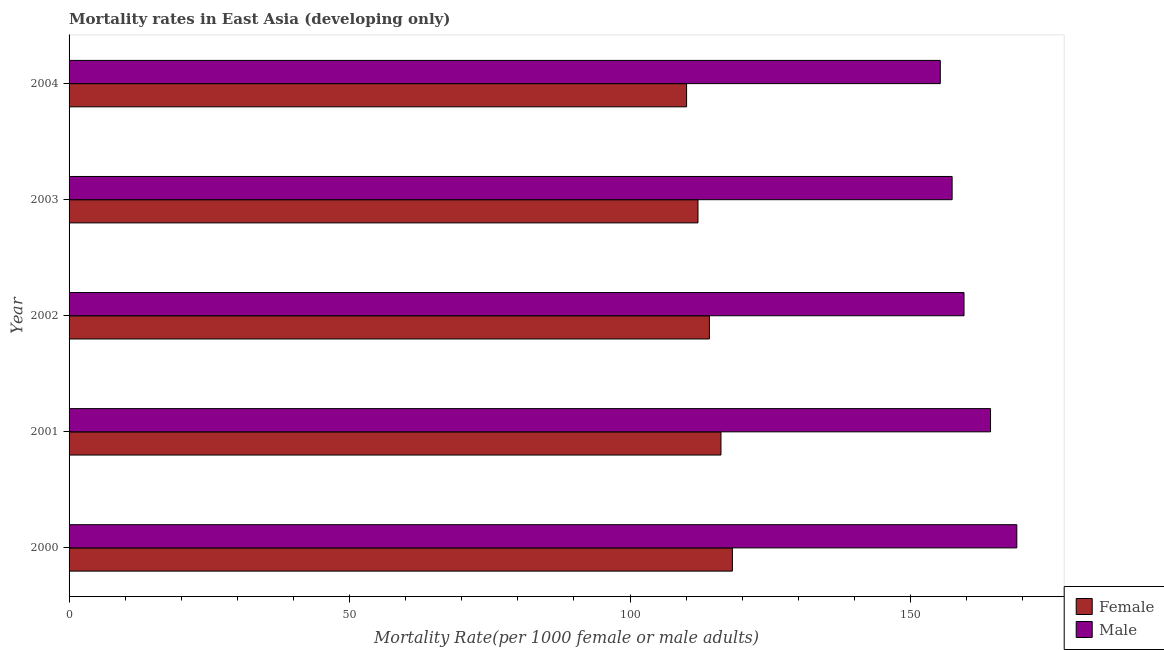What is the female mortality rate in 2004?
Your answer should be very brief. 110.07. Across all years, what is the maximum female mortality rate?
Make the answer very short. 118.24. Across all years, what is the minimum male mortality rate?
Your answer should be very brief. 155.29. In which year was the female mortality rate minimum?
Your answer should be very brief. 2004. What is the total female mortality rate in the graph?
Offer a terse response. 570.75. What is the difference between the male mortality rate in 2002 and that in 2004?
Offer a terse response. 4.23. What is the difference between the male mortality rate in 2000 and the female mortality rate in 2003?
Keep it short and to the point. 56.83. What is the average female mortality rate per year?
Give a very brief answer. 114.15. In the year 2002, what is the difference between the male mortality rate and female mortality rate?
Keep it short and to the point. 45.39. What is the ratio of the female mortality rate in 2000 to that in 2002?
Your response must be concise. 1.04. Is the female mortality rate in 2001 less than that in 2003?
Provide a succinct answer. No. What is the difference between the highest and the second highest male mortality rate?
Your answer should be compact. 4.68. What is the difference between the highest and the lowest female mortality rate?
Offer a very short reply. 8.17. Is the sum of the male mortality rate in 2002 and 2003 greater than the maximum female mortality rate across all years?
Provide a succinct answer. Yes. What does the 2nd bar from the bottom in 2003 represents?
Keep it short and to the point. Male. Are all the bars in the graph horizontal?
Keep it short and to the point. Yes. Are the values on the major ticks of X-axis written in scientific E-notation?
Provide a short and direct response. No. Does the graph contain any zero values?
Make the answer very short. No. How many legend labels are there?
Give a very brief answer. 2. How are the legend labels stacked?
Provide a succinct answer. Vertical. What is the title of the graph?
Keep it short and to the point. Mortality rates in East Asia (developing only). What is the label or title of the X-axis?
Your answer should be very brief. Mortality Rate(per 1000 female or male adults). What is the Mortality Rate(per 1000 female or male adults) of Female in 2000?
Give a very brief answer. 118.24. What is the Mortality Rate(per 1000 female or male adults) in Male in 2000?
Keep it short and to the point. 168.93. What is the Mortality Rate(per 1000 female or male adults) in Female in 2001?
Provide a short and direct response. 116.2. What is the Mortality Rate(per 1000 female or male adults) in Male in 2001?
Provide a short and direct response. 164.25. What is the Mortality Rate(per 1000 female or male adults) of Female in 2002?
Provide a short and direct response. 114.14. What is the Mortality Rate(per 1000 female or male adults) in Male in 2002?
Your answer should be compact. 159.52. What is the Mortality Rate(per 1000 female or male adults) in Female in 2003?
Your answer should be compact. 112.1. What is the Mortality Rate(per 1000 female or male adults) of Male in 2003?
Your response must be concise. 157.4. What is the Mortality Rate(per 1000 female or male adults) in Female in 2004?
Ensure brevity in your answer.  110.07. What is the Mortality Rate(per 1000 female or male adults) of Male in 2004?
Your answer should be compact. 155.29. Across all years, what is the maximum Mortality Rate(per 1000 female or male adults) in Female?
Your answer should be compact. 118.24. Across all years, what is the maximum Mortality Rate(per 1000 female or male adults) of Male?
Offer a terse response. 168.93. Across all years, what is the minimum Mortality Rate(per 1000 female or male adults) in Female?
Keep it short and to the point. 110.07. Across all years, what is the minimum Mortality Rate(per 1000 female or male adults) of Male?
Offer a very short reply. 155.29. What is the total Mortality Rate(per 1000 female or male adults) in Female in the graph?
Give a very brief answer. 570.75. What is the total Mortality Rate(per 1000 female or male adults) of Male in the graph?
Offer a terse response. 805.41. What is the difference between the Mortality Rate(per 1000 female or male adults) in Female in 2000 and that in 2001?
Make the answer very short. 2.04. What is the difference between the Mortality Rate(per 1000 female or male adults) in Male in 2000 and that in 2001?
Your answer should be compact. 4.68. What is the difference between the Mortality Rate(per 1000 female or male adults) in Female in 2000 and that in 2002?
Your response must be concise. 4.1. What is the difference between the Mortality Rate(per 1000 female or male adults) of Male in 2000 and that in 2002?
Your answer should be compact. 9.41. What is the difference between the Mortality Rate(per 1000 female or male adults) of Female in 2000 and that in 2003?
Make the answer very short. 6.13. What is the difference between the Mortality Rate(per 1000 female or male adults) of Male in 2000 and that in 2003?
Your answer should be very brief. 11.53. What is the difference between the Mortality Rate(per 1000 female or male adults) in Female in 2000 and that in 2004?
Offer a terse response. 8.17. What is the difference between the Mortality Rate(per 1000 female or male adults) in Male in 2000 and that in 2004?
Give a very brief answer. 13.64. What is the difference between the Mortality Rate(per 1000 female or male adults) in Female in 2001 and that in 2002?
Provide a short and direct response. 2.06. What is the difference between the Mortality Rate(per 1000 female or male adults) of Male in 2001 and that in 2002?
Ensure brevity in your answer.  4.73. What is the difference between the Mortality Rate(per 1000 female or male adults) of Female in 2001 and that in 2003?
Provide a succinct answer. 4.1. What is the difference between the Mortality Rate(per 1000 female or male adults) of Male in 2001 and that in 2003?
Provide a short and direct response. 6.85. What is the difference between the Mortality Rate(per 1000 female or male adults) in Female in 2001 and that in 2004?
Provide a short and direct response. 6.13. What is the difference between the Mortality Rate(per 1000 female or male adults) of Male in 2001 and that in 2004?
Make the answer very short. 8.96. What is the difference between the Mortality Rate(per 1000 female or male adults) in Female in 2002 and that in 2003?
Your answer should be compact. 2.03. What is the difference between the Mortality Rate(per 1000 female or male adults) in Male in 2002 and that in 2003?
Provide a short and direct response. 2.12. What is the difference between the Mortality Rate(per 1000 female or male adults) in Female in 2002 and that in 2004?
Provide a succinct answer. 4.07. What is the difference between the Mortality Rate(per 1000 female or male adults) in Male in 2002 and that in 2004?
Ensure brevity in your answer.  4.23. What is the difference between the Mortality Rate(per 1000 female or male adults) in Female in 2003 and that in 2004?
Offer a very short reply. 2.03. What is the difference between the Mortality Rate(per 1000 female or male adults) in Male in 2003 and that in 2004?
Your answer should be compact. 2.11. What is the difference between the Mortality Rate(per 1000 female or male adults) in Female in 2000 and the Mortality Rate(per 1000 female or male adults) in Male in 2001?
Offer a very short reply. -46.01. What is the difference between the Mortality Rate(per 1000 female or male adults) in Female in 2000 and the Mortality Rate(per 1000 female or male adults) in Male in 2002?
Offer a terse response. -41.29. What is the difference between the Mortality Rate(per 1000 female or male adults) of Female in 2000 and the Mortality Rate(per 1000 female or male adults) of Male in 2003?
Provide a succinct answer. -39.17. What is the difference between the Mortality Rate(per 1000 female or male adults) in Female in 2000 and the Mortality Rate(per 1000 female or male adults) in Male in 2004?
Offer a very short reply. -37.06. What is the difference between the Mortality Rate(per 1000 female or male adults) in Female in 2001 and the Mortality Rate(per 1000 female or male adults) in Male in 2002?
Give a very brief answer. -43.32. What is the difference between the Mortality Rate(per 1000 female or male adults) in Female in 2001 and the Mortality Rate(per 1000 female or male adults) in Male in 2003?
Give a very brief answer. -41.2. What is the difference between the Mortality Rate(per 1000 female or male adults) of Female in 2001 and the Mortality Rate(per 1000 female or male adults) of Male in 2004?
Give a very brief answer. -39.1. What is the difference between the Mortality Rate(per 1000 female or male adults) of Female in 2002 and the Mortality Rate(per 1000 female or male adults) of Male in 2003?
Your response must be concise. -43.27. What is the difference between the Mortality Rate(per 1000 female or male adults) in Female in 2002 and the Mortality Rate(per 1000 female or male adults) in Male in 2004?
Make the answer very short. -41.16. What is the difference between the Mortality Rate(per 1000 female or male adults) of Female in 2003 and the Mortality Rate(per 1000 female or male adults) of Male in 2004?
Offer a very short reply. -43.19. What is the average Mortality Rate(per 1000 female or male adults) in Female per year?
Offer a very short reply. 114.15. What is the average Mortality Rate(per 1000 female or male adults) in Male per year?
Provide a short and direct response. 161.08. In the year 2000, what is the difference between the Mortality Rate(per 1000 female or male adults) of Female and Mortality Rate(per 1000 female or male adults) of Male?
Your answer should be very brief. -50.7. In the year 2001, what is the difference between the Mortality Rate(per 1000 female or male adults) of Female and Mortality Rate(per 1000 female or male adults) of Male?
Keep it short and to the point. -48.05. In the year 2002, what is the difference between the Mortality Rate(per 1000 female or male adults) of Female and Mortality Rate(per 1000 female or male adults) of Male?
Your answer should be compact. -45.39. In the year 2003, what is the difference between the Mortality Rate(per 1000 female or male adults) of Female and Mortality Rate(per 1000 female or male adults) of Male?
Offer a terse response. -45.3. In the year 2004, what is the difference between the Mortality Rate(per 1000 female or male adults) in Female and Mortality Rate(per 1000 female or male adults) in Male?
Ensure brevity in your answer.  -45.22. What is the ratio of the Mortality Rate(per 1000 female or male adults) in Female in 2000 to that in 2001?
Make the answer very short. 1.02. What is the ratio of the Mortality Rate(per 1000 female or male adults) of Male in 2000 to that in 2001?
Offer a very short reply. 1.03. What is the ratio of the Mortality Rate(per 1000 female or male adults) of Female in 2000 to that in 2002?
Your response must be concise. 1.04. What is the ratio of the Mortality Rate(per 1000 female or male adults) in Male in 2000 to that in 2002?
Provide a short and direct response. 1.06. What is the ratio of the Mortality Rate(per 1000 female or male adults) of Female in 2000 to that in 2003?
Keep it short and to the point. 1.05. What is the ratio of the Mortality Rate(per 1000 female or male adults) in Male in 2000 to that in 2003?
Make the answer very short. 1.07. What is the ratio of the Mortality Rate(per 1000 female or male adults) of Female in 2000 to that in 2004?
Ensure brevity in your answer.  1.07. What is the ratio of the Mortality Rate(per 1000 female or male adults) of Male in 2000 to that in 2004?
Provide a short and direct response. 1.09. What is the ratio of the Mortality Rate(per 1000 female or male adults) of Female in 2001 to that in 2002?
Keep it short and to the point. 1.02. What is the ratio of the Mortality Rate(per 1000 female or male adults) of Male in 2001 to that in 2002?
Provide a short and direct response. 1.03. What is the ratio of the Mortality Rate(per 1000 female or male adults) in Female in 2001 to that in 2003?
Offer a terse response. 1.04. What is the ratio of the Mortality Rate(per 1000 female or male adults) of Male in 2001 to that in 2003?
Ensure brevity in your answer.  1.04. What is the ratio of the Mortality Rate(per 1000 female or male adults) of Female in 2001 to that in 2004?
Your response must be concise. 1.06. What is the ratio of the Mortality Rate(per 1000 female or male adults) of Male in 2001 to that in 2004?
Your answer should be compact. 1.06. What is the ratio of the Mortality Rate(per 1000 female or male adults) of Female in 2002 to that in 2003?
Provide a short and direct response. 1.02. What is the ratio of the Mortality Rate(per 1000 female or male adults) in Male in 2002 to that in 2003?
Your answer should be very brief. 1.01. What is the ratio of the Mortality Rate(per 1000 female or male adults) in Female in 2002 to that in 2004?
Keep it short and to the point. 1.04. What is the ratio of the Mortality Rate(per 1000 female or male adults) in Male in 2002 to that in 2004?
Offer a terse response. 1.03. What is the ratio of the Mortality Rate(per 1000 female or male adults) of Female in 2003 to that in 2004?
Ensure brevity in your answer.  1.02. What is the ratio of the Mortality Rate(per 1000 female or male adults) of Male in 2003 to that in 2004?
Make the answer very short. 1.01. What is the difference between the highest and the second highest Mortality Rate(per 1000 female or male adults) of Female?
Keep it short and to the point. 2.04. What is the difference between the highest and the second highest Mortality Rate(per 1000 female or male adults) in Male?
Provide a succinct answer. 4.68. What is the difference between the highest and the lowest Mortality Rate(per 1000 female or male adults) in Female?
Ensure brevity in your answer.  8.17. What is the difference between the highest and the lowest Mortality Rate(per 1000 female or male adults) in Male?
Make the answer very short. 13.64. 